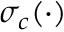<formula> <loc_0><loc_0><loc_500><loc_500>\sigma _ { c } ( \cdot )</formula> 